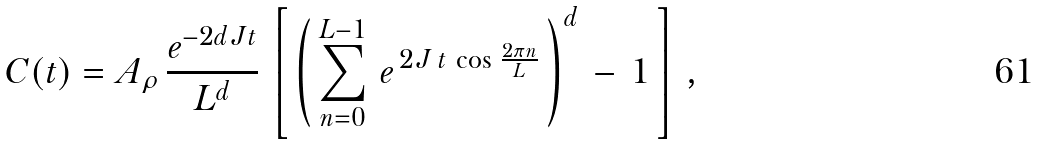Convert formula to latex. <formula><loc_0><loc_0><loc_500><loc_500>C ( t ) = A _ { \rho } \, \frac { e ^ { - 2 d J t } } { L ^ { d } } \, \left [ \, \left ( \, \sum _ { n = 0 } ^ { L - 1 } \, e ^ { \, 2 J \, t \, \cos \, \frac { 2 \pi n } { L } } \, \right ) ^ { d } \, - \, 1 \, \right ] \, ,</formula> 